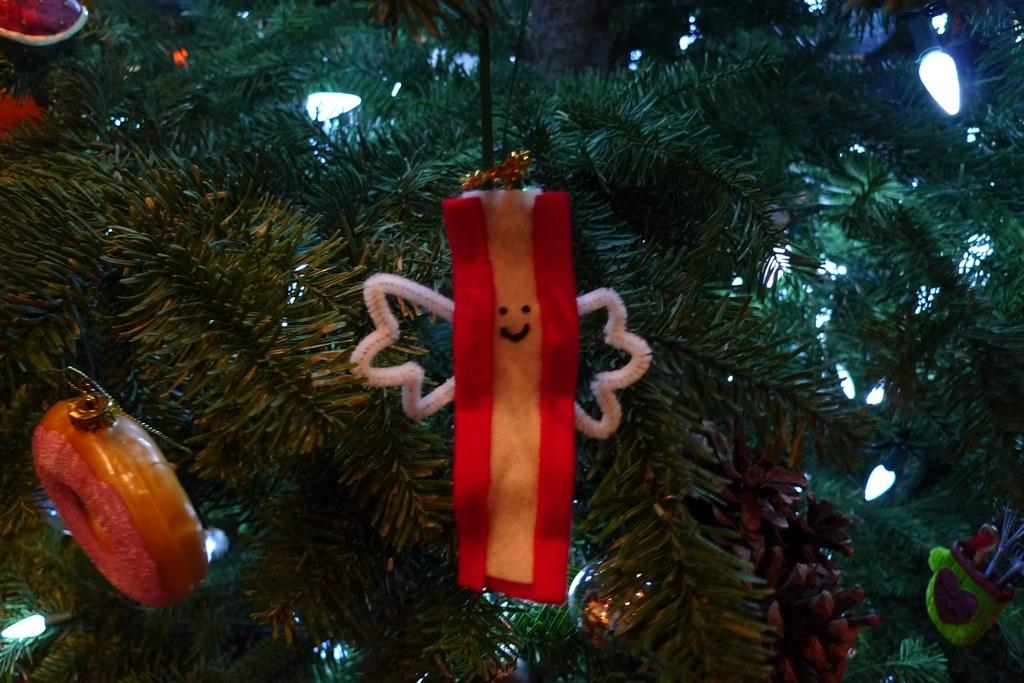What type of tree is in the image? There is a Christmas tree in the image. What decorations are on the Christmas tree? Lights and Christmas ornaments are visible on the Christmas tree. How many eggs are on the scarecrow in the image? There is no scarecrow or eggs present in the image; it features a Christmas tree with lights and ornaments. 